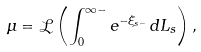Convert formula to latex. <formula><loc_0><loc_0><loc_500><loc_500>\mu = \mathcal { L } \left ( \int _ { 0 } ^ { \infty - } e ^ { - \xi _ { s - } } \, d L _ { s } \right ) ,</formula> 